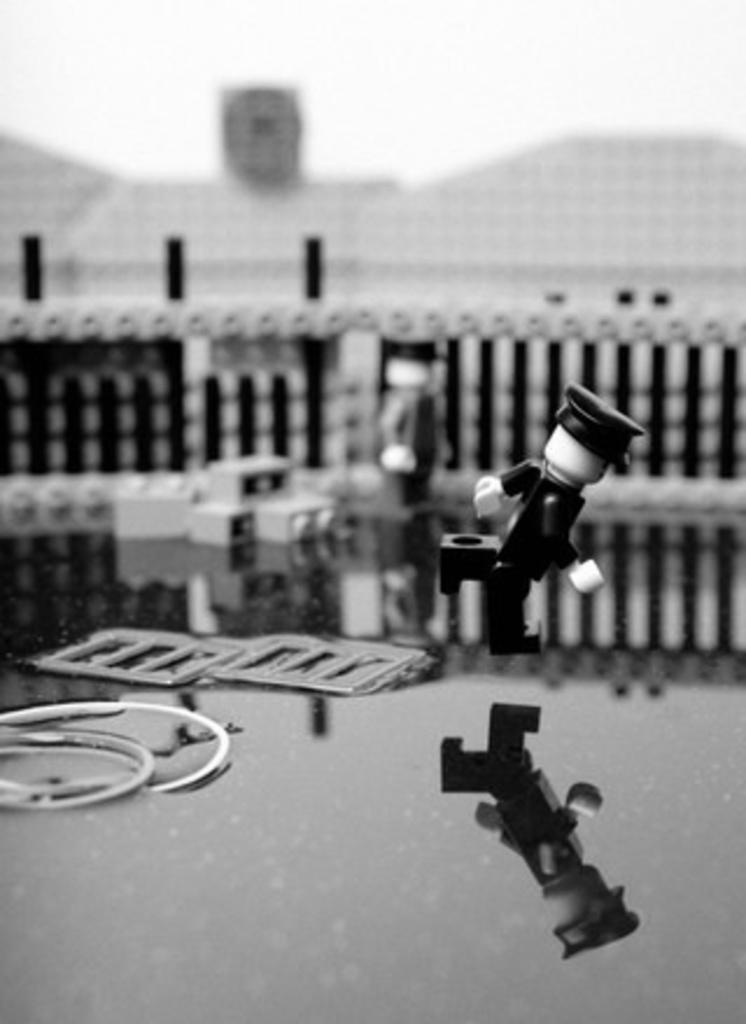Could you give a brief overview of what you see in this image? This is a black and white picture. Here we can see a toy and a fence. There is a blur background. 